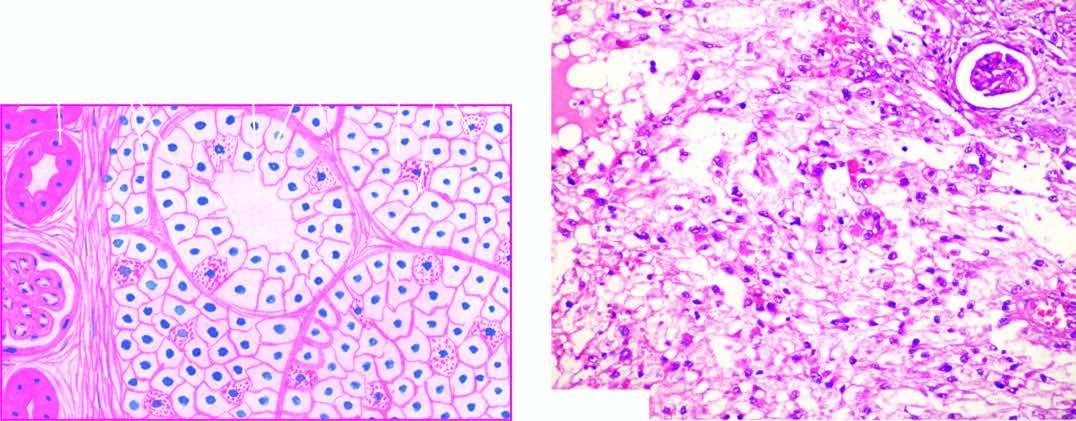s the stroma composed of fine and delicate fibrous tissue?
Answer the question using a single word or phrase. Yes 